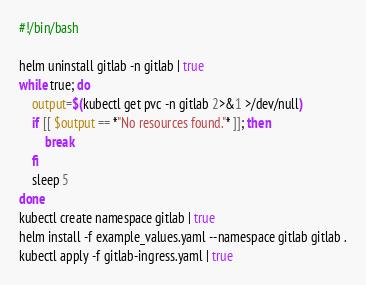Convert code to text. <code><loc_0><loc_0><loc_500><loc_500><_Bash_>#!/bin/bash

helm uninstall gitlab -n gitlab | true
while true; do
    output=$(kubectl get pvc -n gitlab 2>&1 >/dev/null)
    if [[ $output == *"No resources found."* ]]; then
        break
    fi
    sleep 5
done
kubectl create namespace gitlab | true
helm install -f example_values.yaml --namespace gitlab gitlab .
kubectl apply -f gitlab-ingress.yaml | true
</code> 